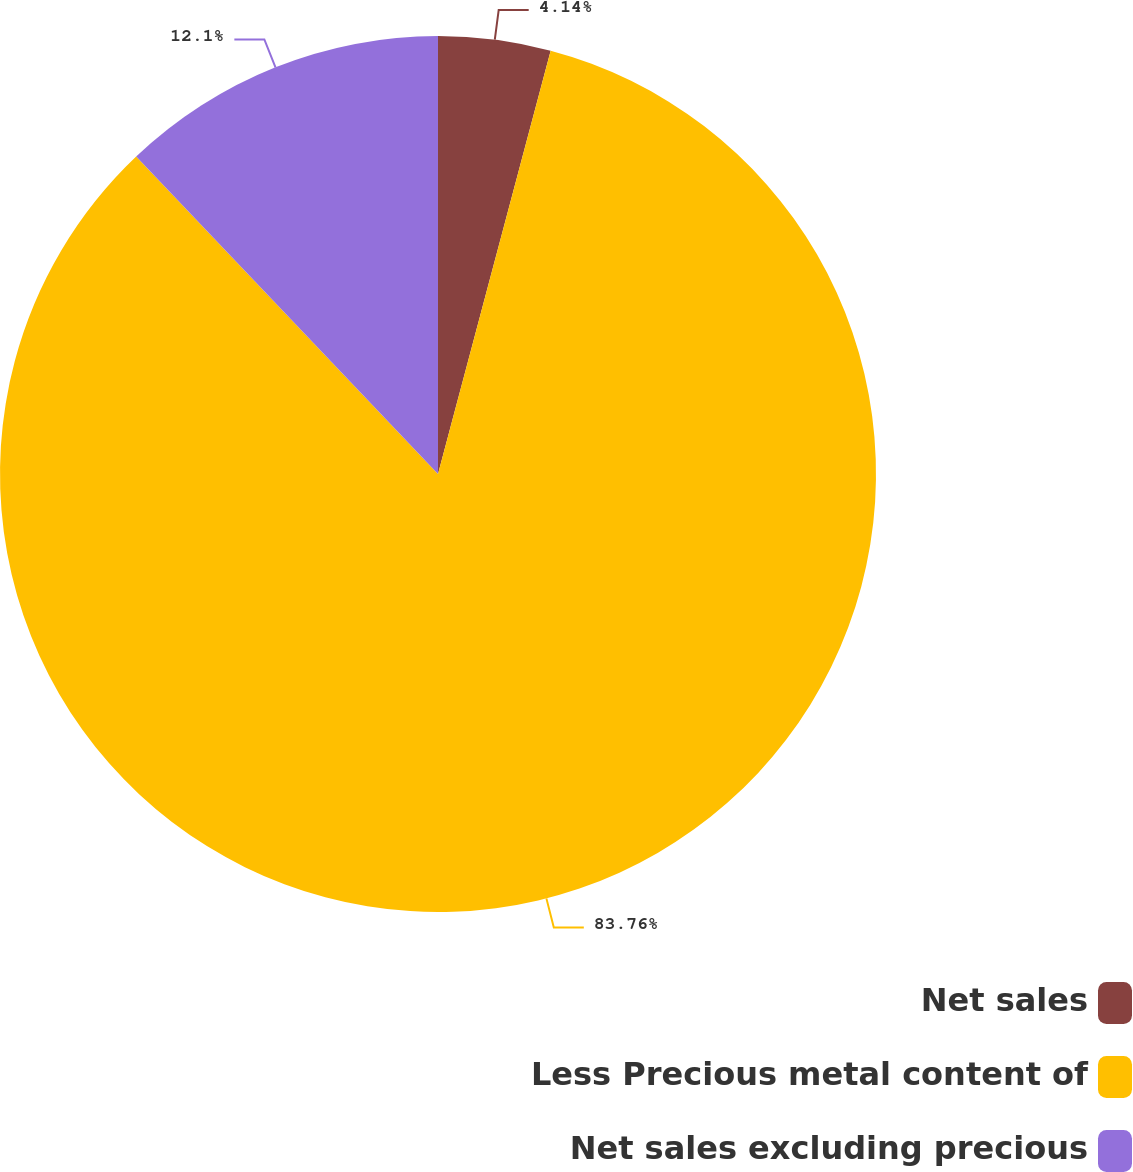<chart> <loc_0><loc_0><loc_500><loc_500><pie_chart><fcel>Net sales<fcel>Less Precious metal content of<fcel>Net sales excluding precious<nl><fcel>4.14%<fcel>83.76%<fcel>12.1%<nl></chart> 